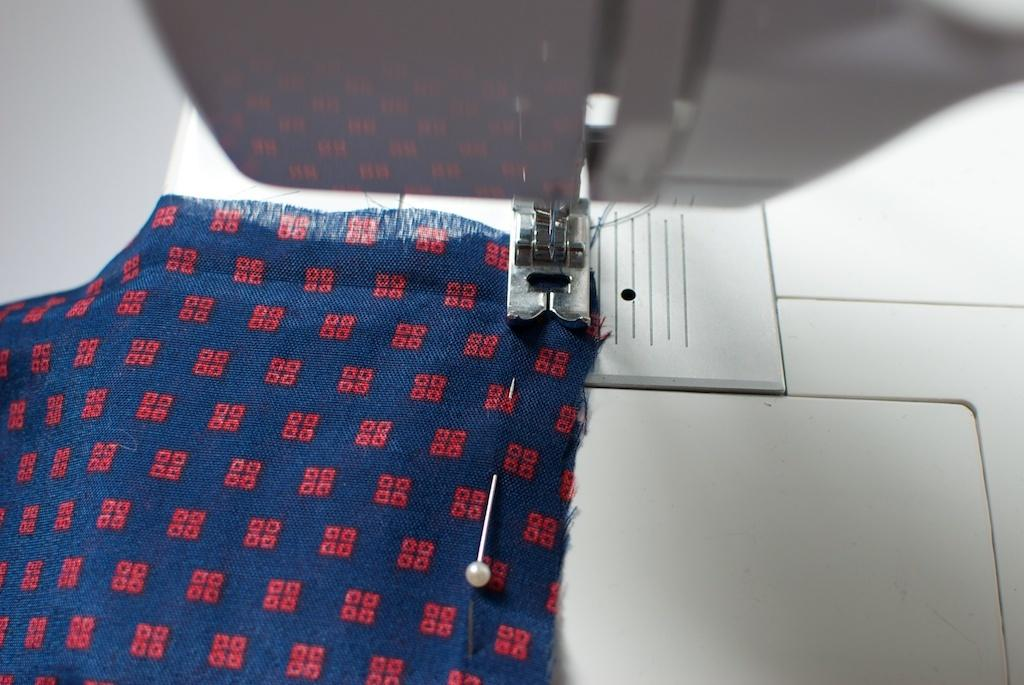What is the main object in the foreground of the image? There is a sewing machine in the foreground of the image. What is placed on the sewing machine? There is a cloth on the sewing machine. Can you describe the cloth in more detail? A pin is attached to the cloth. What is the name of the person who regrets not walking on the sidewalk in the image? There is no person or sidewalk present in the image, so it is not possible to determine who might regret not walking on a sidewalk. 